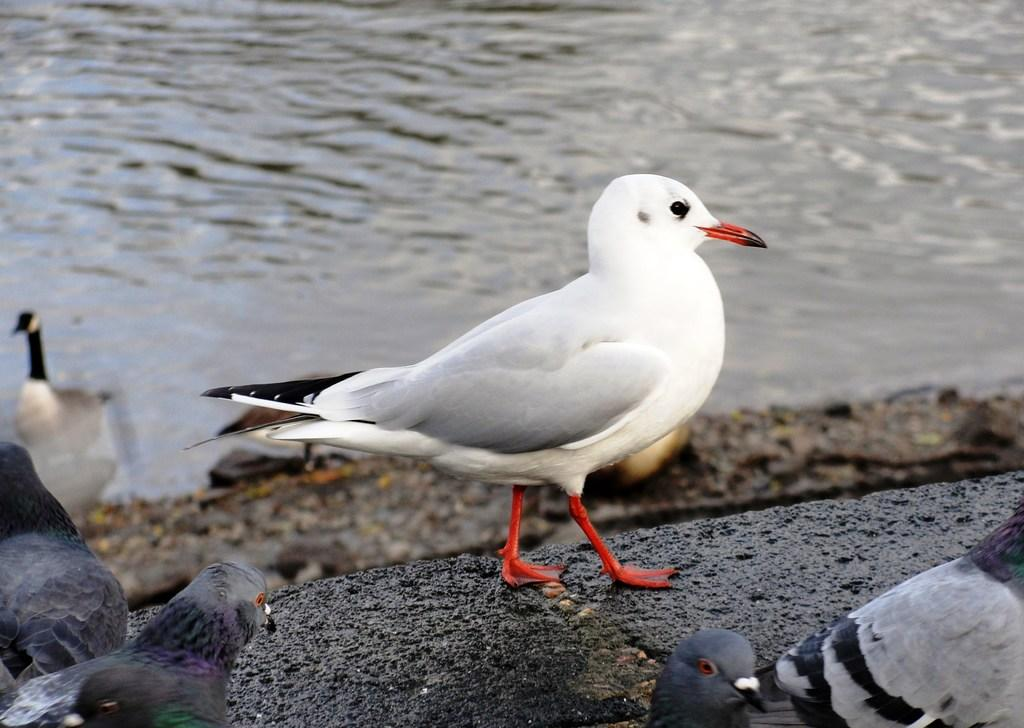What type of animals can be seen in the image? Birds can be seen in the image. Where are the birds located in relation to the water? The birds are near the water. What type of silk is being used by the birds in the image? There is no silk present in the image, and the birds are not using any silk. 